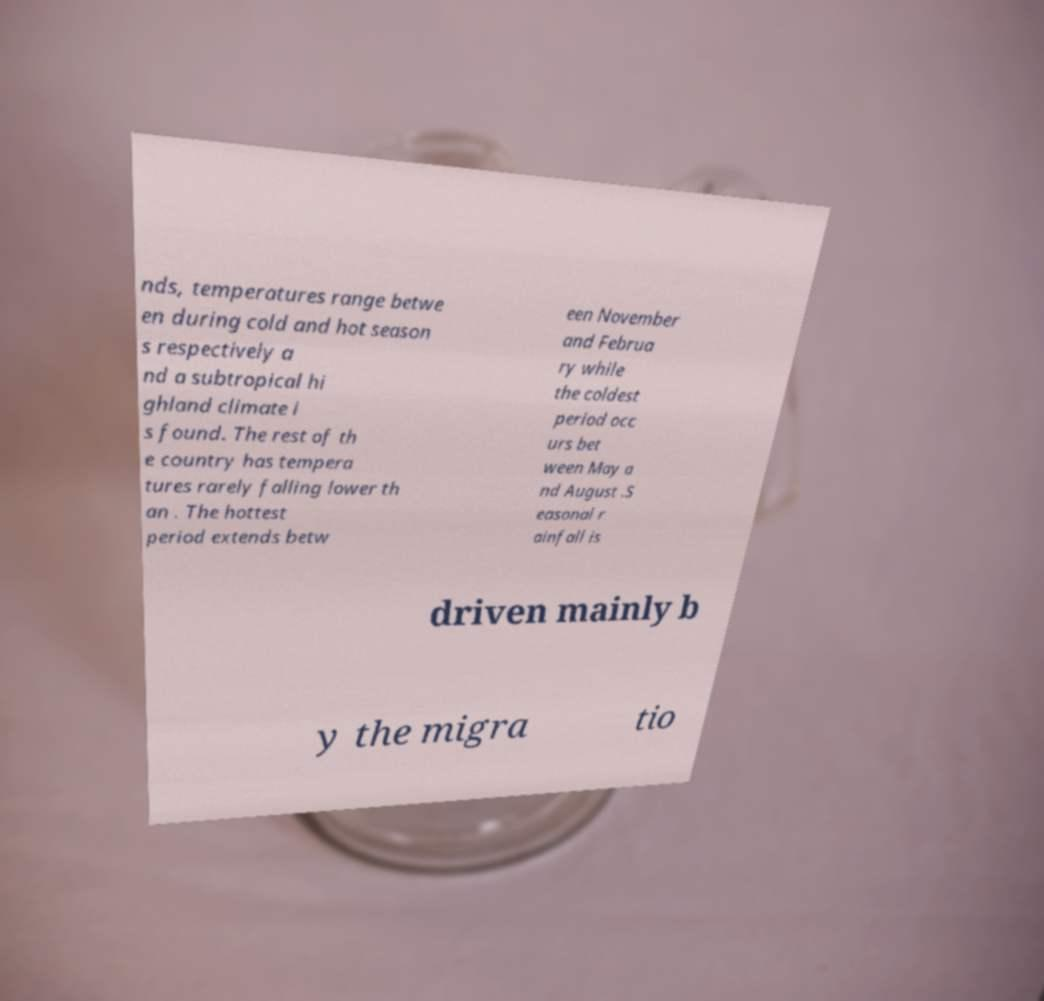Could you extract and type out the text from this image? nds, temperatures range betwe en during cold and hot season s respectively a nd a subtropical hi ghland climate i s found. The rest of th e country has tempera tures rarely falling lower th an . The hottest period extends betw een November and Februa ry while the coldest period occ urs bet ween May a nd August .S easonal r ainfall is driven mainly b y the migra tio 